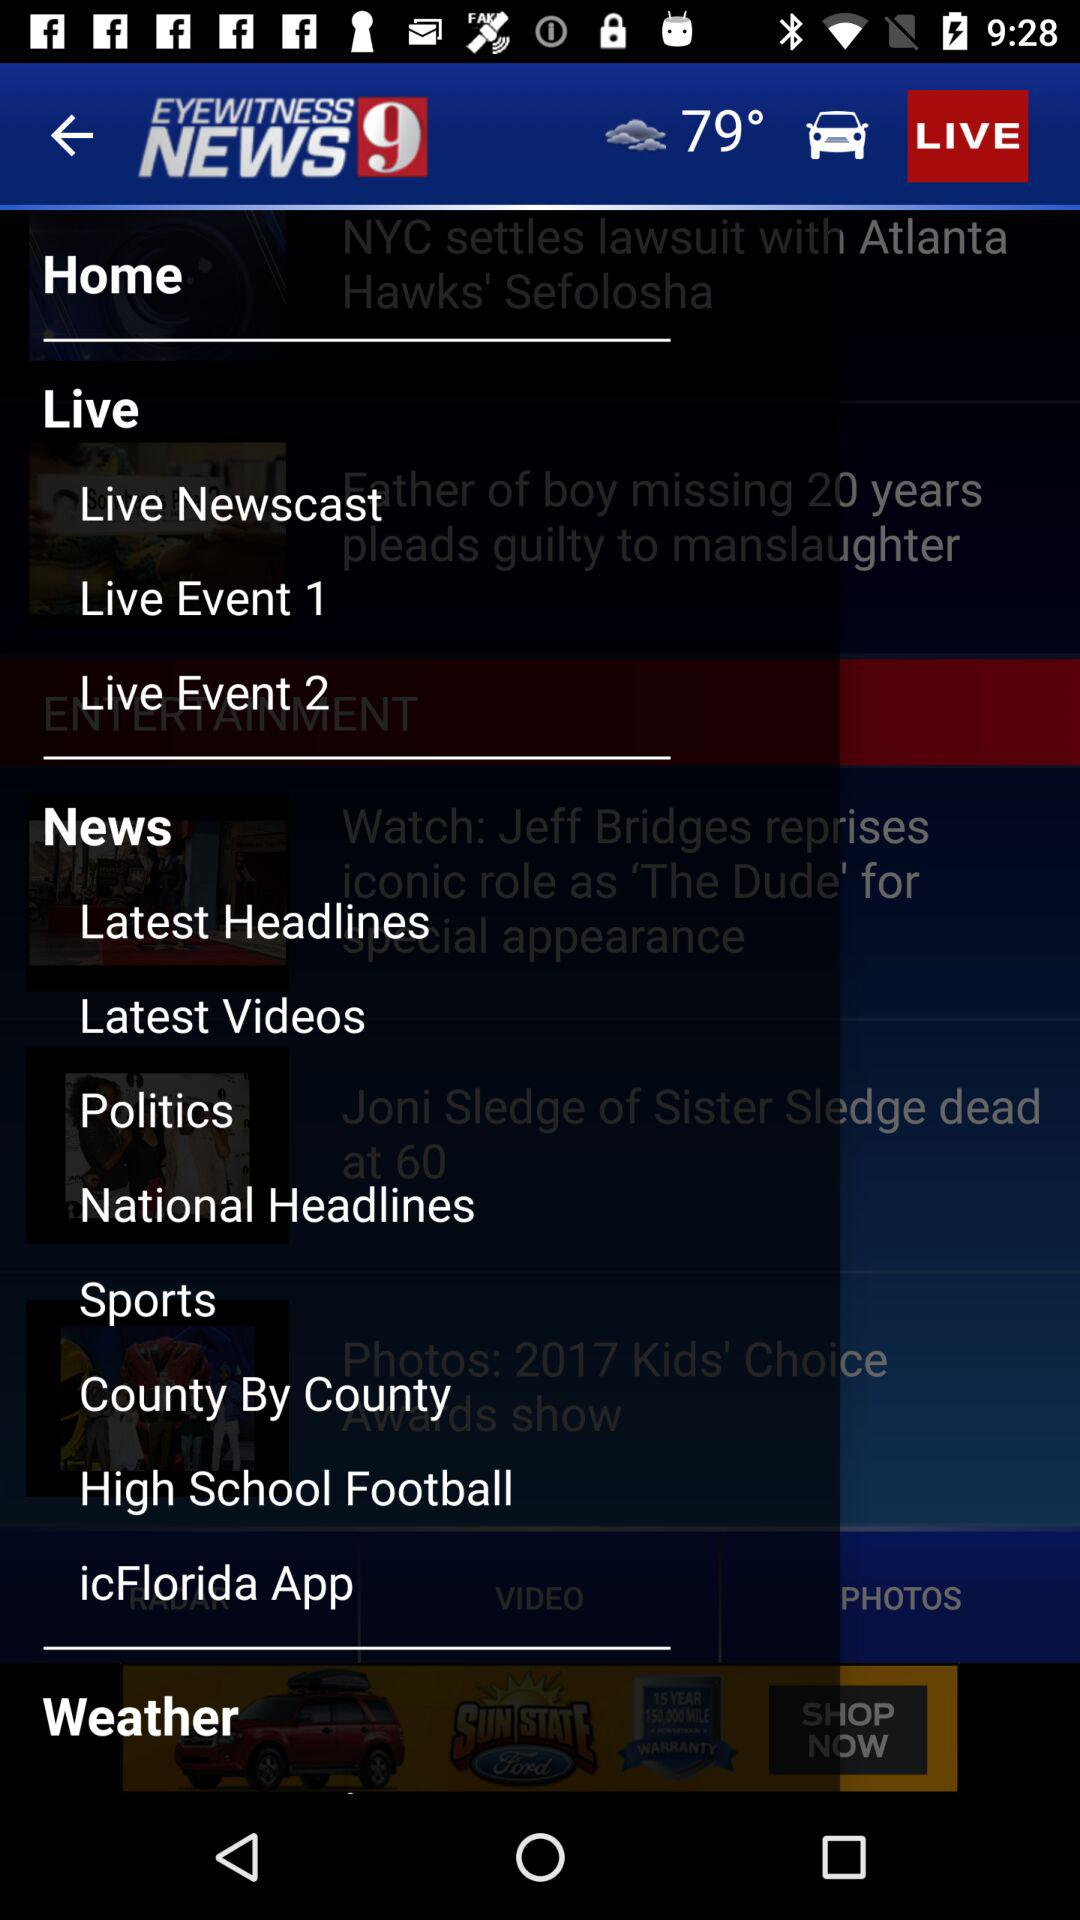What is the name of the application? The name of the application is "EYEWITNESS NEWS9". 